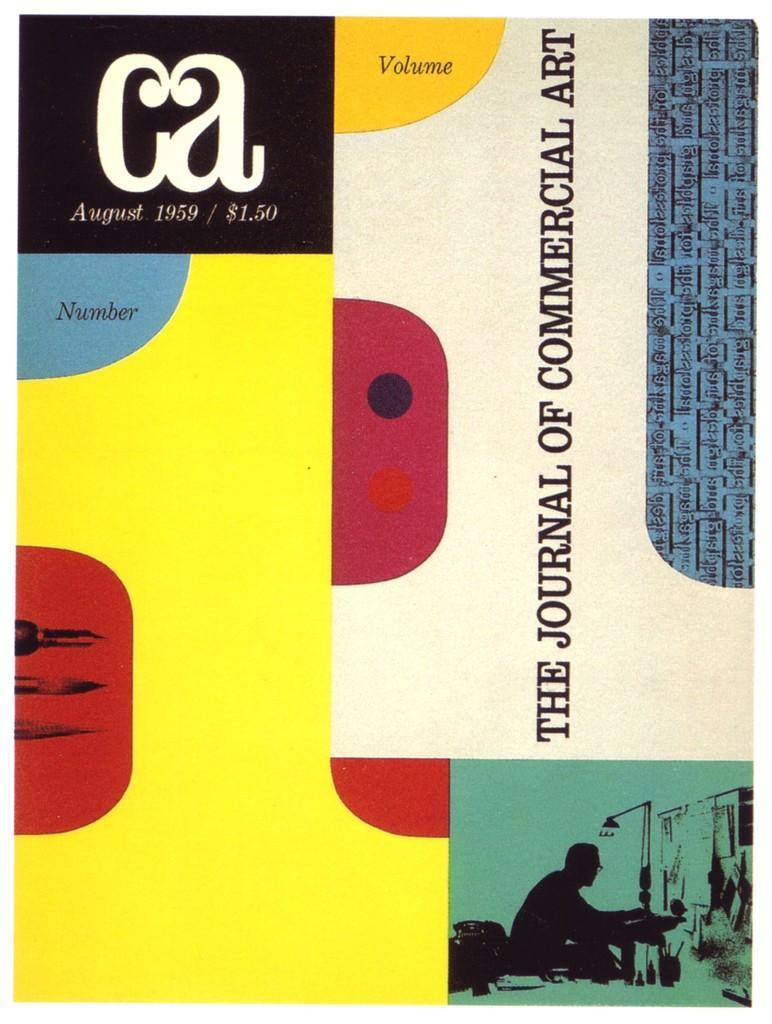Could you give a brief overview of what you see in this image? This a graphic edited image with some texts on the right side top corner and on the left side with some color shapes on the bottom. 